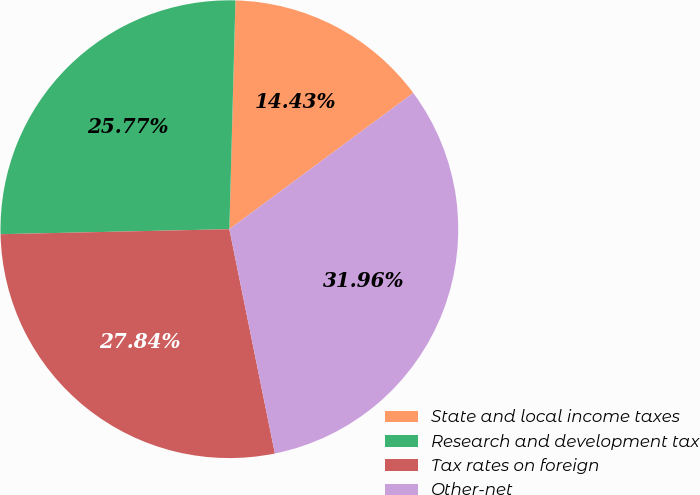Convert chart. <chart><loc_0><loc_0><loc_500><loc_500><pie_chart><fcel>State and local income taxes<fcel>Research and development tax<fcel>Tax rates on foreign<fcel>Other-net<nl><fcel>14.43%<fcel>25.77%<fcel>27.84%<fcel>31.96%<nl></chart> 